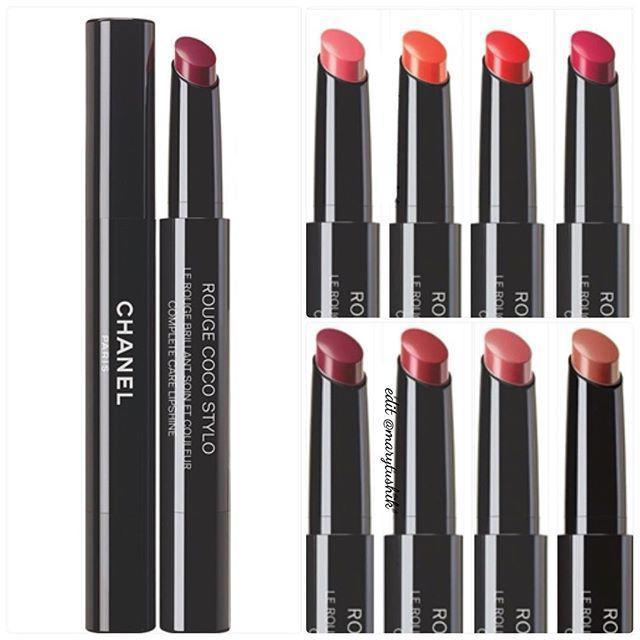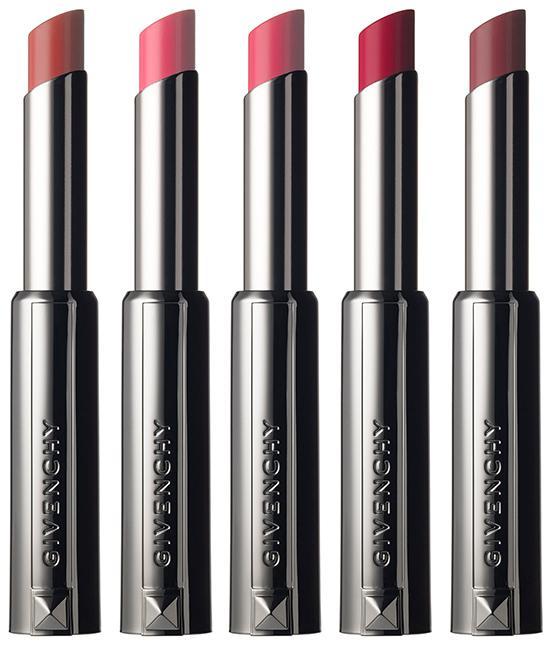The first image is the image on the left, the second image is the image on the right. For the images displayed, is the sentence "There are exactly three lip makeups in the image on the right." factually correct? Answer yes or no. No. 